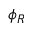Convert formula to latex. <formula><loc_0><loc_0><loc_500><loc_500>\phi _ { R }</formula> 